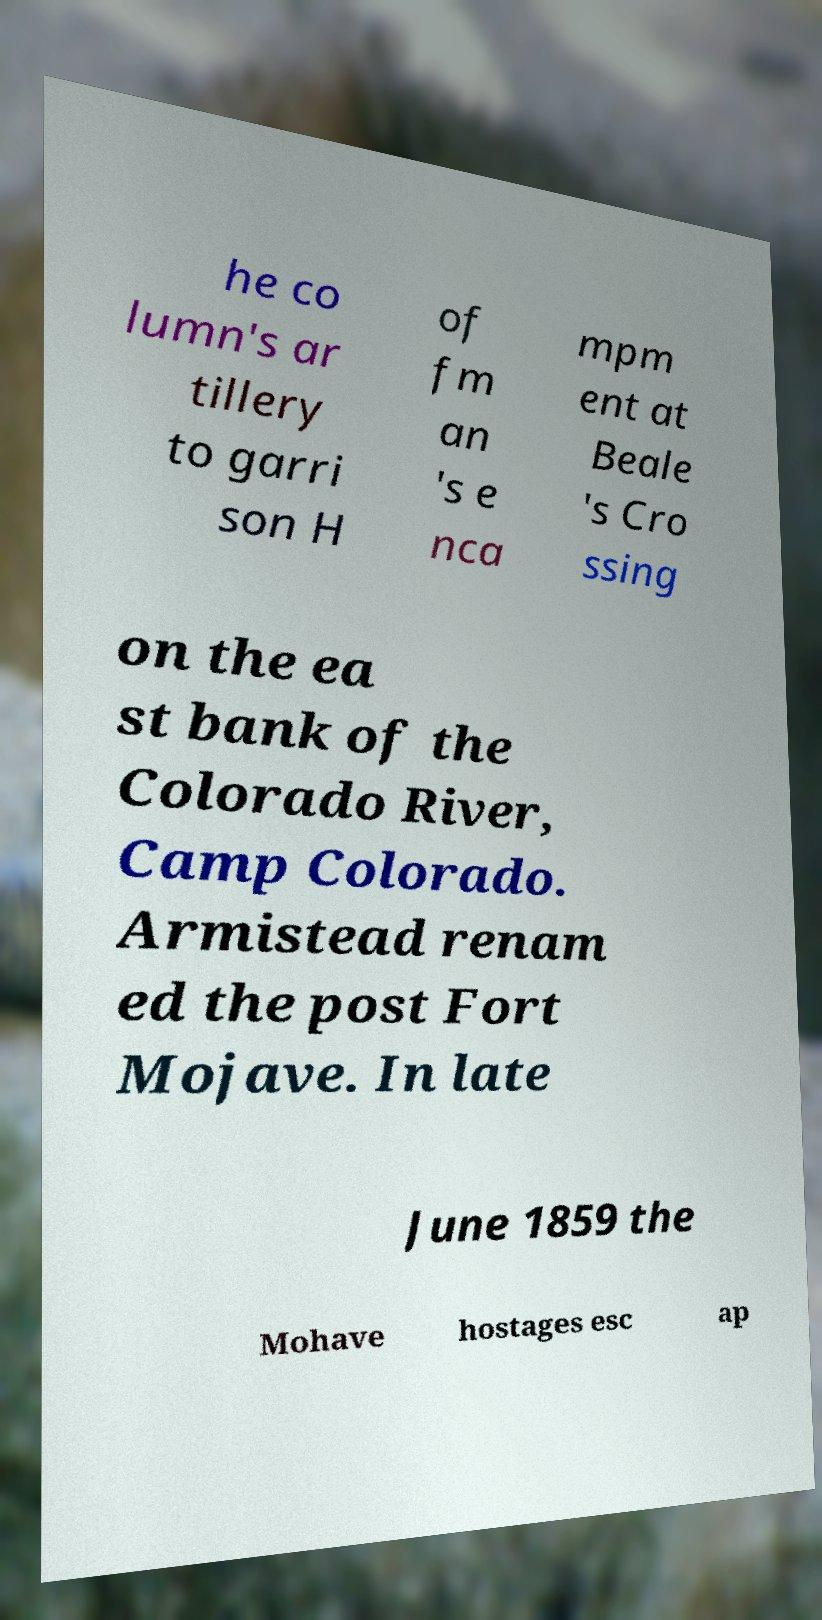Please read and relay the text visible in this image. What does it say? he co lumn's ar tillery to garri son H of fm an 's e nca mpm ent at Beale 's Cro ssing on the ea st bank of the Colorado River, Camp Colorado. Armistead renam ed the post Fort Mojave. In late June 1859 the Mohave hostages esc ap 